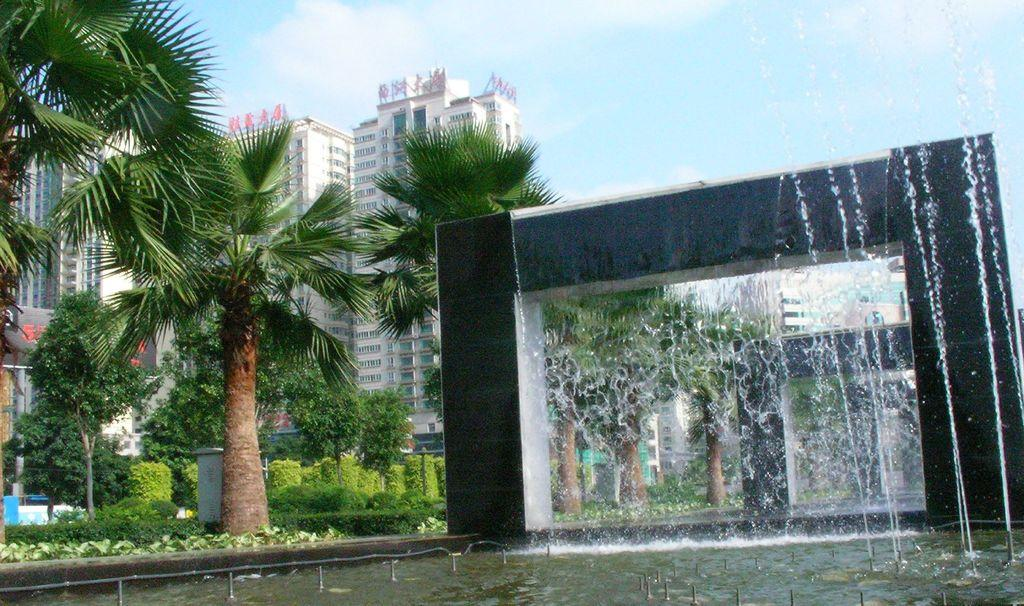What natural element is visible in the image? Water is visible in the image. What type of vegetation can be seen in the image? There are plants and trees in the image. What type of man-made structures are present in the image? There are buildings in the image. What is visible at the top of the image? The sky is visible at the top of the image. How many apples are visible on the self in the image? There is no self or apples present in the image. What type of scale is used to weigh the plants in the image? There is no scale present in the image, and the plants are not being weighed. 